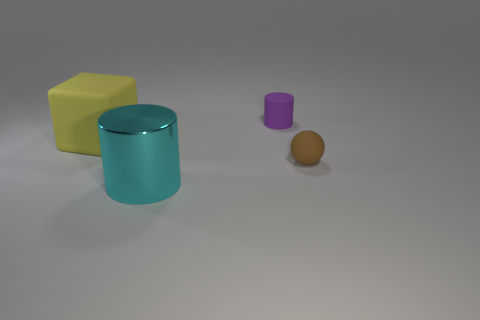Add 4 matte cylinders. How many objects exist? 8 Subtract all cubes. How many objects are left? 3 Subtract all gray metallic objects. Subtract all big cylinders. How many objects are left? 3 Add 1 purple matte objects. How many purple matte objects are left? 2 Add 1 big green matte cylinders. How many big green matte cylinders exist? 1 Subtract 1 yellow cubes. How many objects are left? 3 